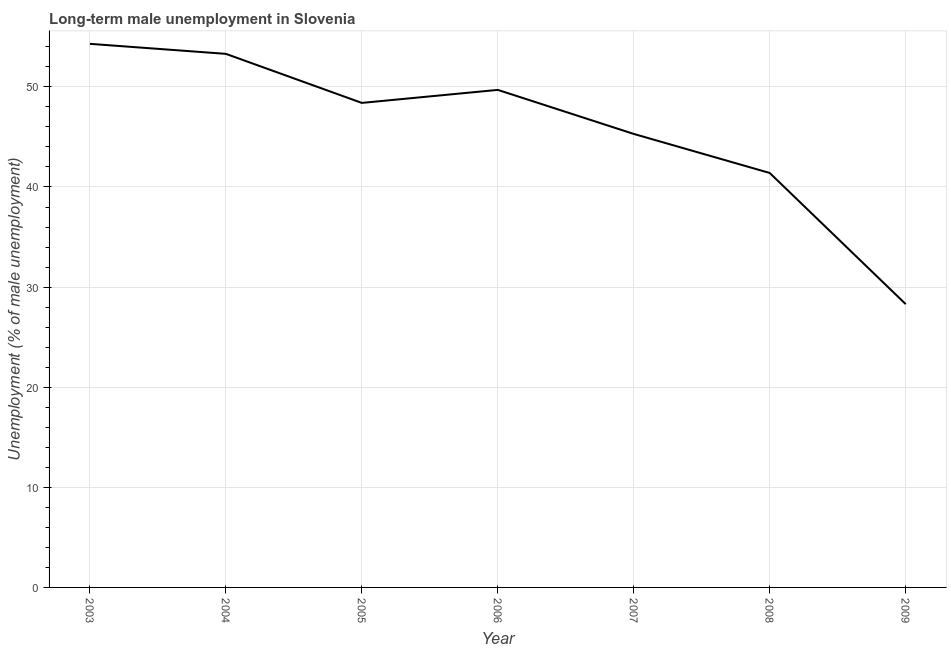What is the long-term male unemployment in 2008?
Keep it short and to the point. 41.4. Across all years, what is the maximum long-term male unemployment?
Ensure brevity in your answer.  54.3. Across all years, what is the minimum long-term male unemployment?
Give a very brief answer. 28.3. In which year was the long-term male unemployment maximum?
Keep it short and to the point. 2003. In which year was the long-term male unemployment minimum?
Provide a short and direct response. 2009. What is the sum of the long-term male unemployment?
Offer a terse response. 320.7. What is the difference between the long-term male unemployment in 2003 and 2005?
Your response must be concise. 5.9. What is the average long-term male unemployment per year?
Provide a succinct answer. 45.81. What is the median long-term male unemployment?
Make the answer very short. 48.4. In how many years, is the long-term male unemployment greater than 4 %?
Offer a terse response. 7. Do a majority of the years between 2005 and 2007 (inclusive) have long-term male unemployment greater than 38 %?
Offer a terse response. Yes. What is the ratio of the long-term male unemployment in 2008 to that in 2009?
Offer a terse response. 1.46. Is the sum of the long-term male unemployment in 2006 and 2009 greater than the maximum long-term male unemployment across all years?
Your answer should be compact. Yes. What is the difference between the highest and the lowest long-term male unemployment?
Offer a terse response. 26. In how many years, is the long-term male unemployment greater than the average long-term male unemployment taken over all years?
Keep it short and to the point. 4. Does the long-term male unemployment monotonically increase over the years?
Your answer should be very brief. No. How many lines are there?
Your answer should be compact. 1. What is the difference between two consecutive major ticks on the Y-axis?
Ensure brevity in your answer.  10. Are the values on the major ticks of Y-axis written in scientific E-notation?
Your response must be concise. No. Does the graph contain any zero values?
Your answer should be compact. No. Does the graph contain grids?
Give a very brief answer. Yes. What is the title of the graph?
Offer a terse response. Long-term male unemployment in Slovenia. What is the label or title of the Y-axis?
Keep it short and to the point. Unemployment (% of male unemployment). What is the Unemployment (% of male unemployment) of 2003?
Provide a succinct answer. 54.3. What is the Unemployment (% of male unemployment) in 2004?
Make the answer very short. 53.3. What is the Unemployment (% of male unemployment) of 2005?
Keep it short and to the point. 48.4. What is the Unemployment (% of male unemployment) of 2006?
Keep it short and to the point. 49.7. What is the Unemployment (% of male unemployment) in 2007?
Offer a very short reply. 45.3. What is the Unemployment (% of male unemployment) of 2008?
Ensure brevity in your answer.  41.4. What is the Unemployment (% of male unemployment) in 2009?
Your response must be concise. 28.3. What is the difference between the Unemployment (% of male unemployment) in 2003 and 2004?
Your answer should be very brief. 1. What is the difference between the Unemployment (% of male unemployment) in 2003 and 2006?
Make the answer very short. 4.6. What is the difference between the Unemployment (% of male unemployment) in 2003 and 2007?
Make the answer very short. 9. What is the difference between the Unemployment (% of male unemployment) in 2004 and 2007?
Offer a very short reply. 8. What is the difference between the Unemployment (% of male unemployment) in 2004 and 2009?
Provide a succinct answer. 25. What is the difference between the Unemployment (% of male unemployment) in 2005 and 2006?
Your answer should be very brief. -1.3. What is the difference between the Unemployment (% of male unemployment) in 2005 and 2007?
Your response must be concise. 3.1. What is the difference between the Unemployment (% of male unemployment) in 2005 and 2008?
Your answer should be compact. 7. What is the difference between the Unemployment (% of male unemployment) in 2005 and 2009?
Offer a terse response. 20.1. What is the difference between the Unemployment (% of male unemployment) in 2006 and 2007?
Provide a succinct answer. 4.4. What is the difference between the Unemployment (% of male unemployment) in 2006 and 2008?
Your answer should be compact. 8.3. What is the difference between the Unemployment (% of male unemployment) in 2006 and 2009?
Offer a terse response. 21.4. What is the difference between the Unemployment (% of male unemployment) in 2007 and 2009?
Provide a succinct answer. 17. What is the ratio of the Unemployment (% of male unemployment) in 2003 to that in 2005?
Your answer should be very brief. 1.12. What is the ratio of the Unemployment (% of male unemployment) in 2003 to that in 2006?
Offer a very short reply. 1.09. What is the ratio of the Unemployment (% of male unemployment) in 2003 to that in 2007?
Keep it short and to the point. 1.2. What is the ratio of the Unemployment (% of male unemployment) in 2003 to that in 2008?
Your answer should be compact. 1.31. What is the ratio of the Unemployment (% of male unemployment) in 2003 to that in 2009?
Make the answer very short. 1.92. What is the ratio of the Unemployment (% of male unemployment) in 2004 to that in 2005?
Provide a succinct answer. 1.1. What is the ratio of the Unemployment (% of male unemployment) in 2004 to that in 2006?
Offer a terse response. 1.07. What is the ratio of the Unemployment (% of male unemployment) in 2004 to that in 2007?
Provide a succinct answer. 1.18. What is the ratio of the Unemployment (% of male unemployment) in 2004 to that in 2008?
Keep it short and to the point. 1.29. What is the ratio of the Unemployment (% of male unemployment) in 2004 to that in 2009?
Your response must be concise. 1.88. What is the ratio of the Unemployment (% of male unemployment) in 2005 to that in 2006?
Offer a terse response. 0.97. What is the ratio of the Unemployment (% of male unemployment) in 2005 to that in 2007?
Keep it short and to the point. 1.07. What is the ratio of the Unemployment (% of male unemployment) in 2005 to that in 2008?
Offer a terse response. 1.17. What is the ratio of the Unemployment (% of male unemployment) in 2005 to that in 2009?
Offer a very short reply. 1.71. What is the ratio of the Unemployment (% of male unemployment) in 2006 to that in 2007?
Provide a short and direct response. 1.1. What is the ratio of the Unemployment (% of male unemployment) in 2006 to that in 2009?
Your response must be concise. 1.76. What is the ratio of the Unemployment (% of male unemployment) in 2007 to that in 2008?
Give a very brief answer. 1.09. What is the ratio of the Unemployment (% of male unemployment) in 2007 to that in 2009?
Make the answer very short. 1.6. What is the ratio of the Unemployment (% of male unemployment) in 2008 to that in 2009?
Provide a short and direct response. 1.46. 